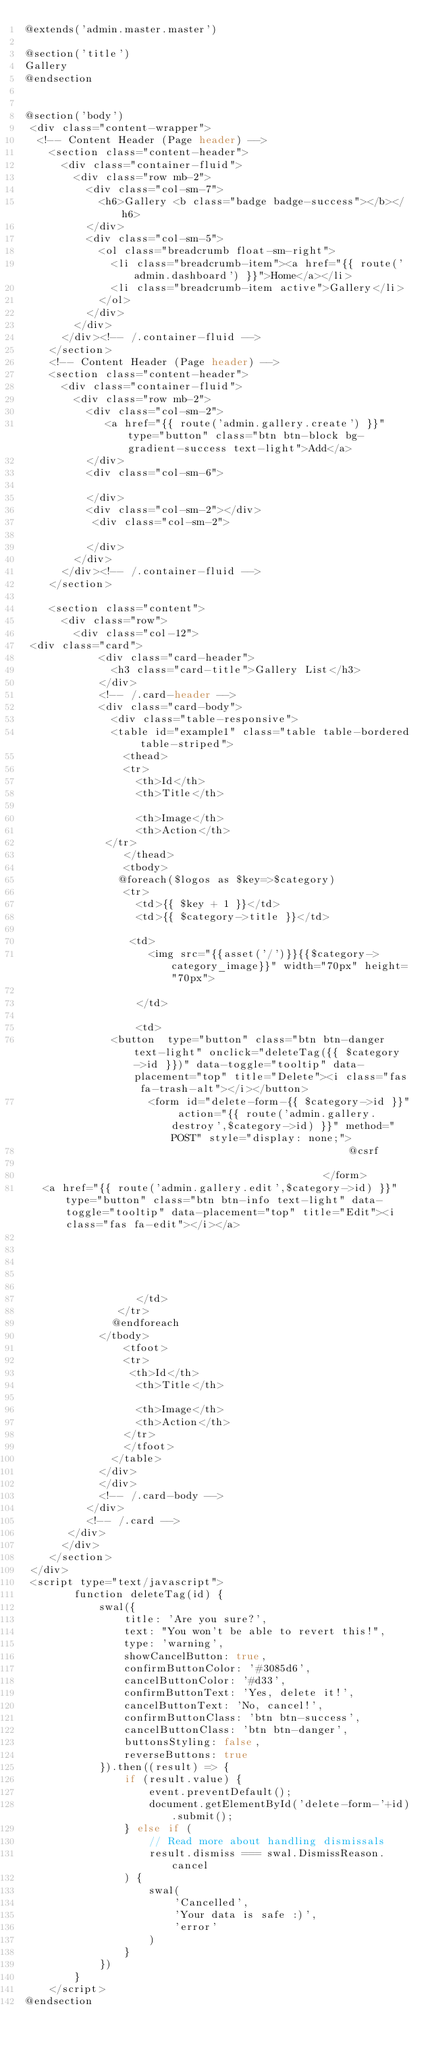<code> <loc_0><loc_0><loc_500><loc_500><_PHP_>@extends('admin.master.master')

@section('title')
Gallery 
@endsection


@section('body')
 <div class="content-wrapper">
  <!-- Content Header (Page header) -->
    <section class="content-header">
      <div class="container-fluid">
        <div class="row mb-2">
          <div class="col-sm-7">
            <h6>Gallery <b class="badge badge-success"></b></h6>
          </div>
          <div class="col-sm-5">
            <ol class="breadcrumb float-sm-right">
              <li class="breadcrumb-item"><a href="{{ route('admin.dashboard') }}">Home</a></li>
              <li class="breadcrumb-item active">Gallery</li>
            </ol>
          </div>
        </div>
      </div><!-- /.container-fluid -->
    </section>
    <!-- Content Header (Page header) -->
    <section class="content-header">
      <div class="container-fluid">
        <div class="row mb-2">
          <div class="col-sm-2">
             <a href="{{ route('admin.gallery.create') }}" type="button" class="btn btn-block bg-gradient-success text-light">Add</a>
          </div>
          <div class="col-sm-6">
            
          </div>
          <div class="col-sm-2"></div>
           <div class="col-sm-2">
           
          </div>
        </div>
      </div><!-- /.container-fluid -->
    </section>
  
    <section class="content">
      <div class="row">
        <div class="col-12">
 <div class="card">
            <div class="card-header">
              <h3 class="card-title">Gallery List</h3>
            </div>
            <!-- /.card-header -->
            <div class="card-body">
              <div class="table-responsive">
              <table id="example1" class="table table-bordered table-striped">
                <thead>
                <tr>
                  <th>Id</th>
                  <th>Title</th>
              
                  <th>Image</th>
                  <th>Action</th>
             </tr>
                </thead>
                <tbody>
               @foreach($logos as $key=>$category)
                <tr>
                  <td>{{ $key + 1 }}</td>
                  <td>{{ $category->title }}</td>
                
                 <td>
                    <img src="{{asset('/')}}{{$category->category_image}}" width="70px" height="70px">
                   
                  </td>
                 
                  <td>
              <button  type="button" class="btn btn-danger text-light" onclick="deleteTag({{ $category->id }})" data-toggle="tooltip" data-placement="top" title="Delete"><i class="fas fa-trash-alt"></i></button>
                    <form id="delete-form-{{ $category->id }}" action="{{ route('admin.gallery.destroy',$category->id) }}" method="POST" style="display: none;">
                                                    @csrf
                                                    
                                                </form>
   <a href="{{ route('admin.gallery.edit',$category->id) }}" type="button" class="btn btn-info text-light" data-toggle="tooltip" data-placement="top" title="Edit"><i class="fas fa-edit"></i></a>

                    
                
               
                
                  </td>
               </tr>
              @endforeach
            </tbody>
                <tfoot>
                <tr>
                 <th>Id</th>
                  <th>Title</th>
              
                  <th>Image</th>
                  <th>Action</th>
                </tr>
                </tfoot>
              </table>
            </div>
            </div>
            <!-- /.card-body -->
          </div>
          <!-- /.card -->
       </div>
      </div>
    </section>
 </div>
 <script type="text/javascript">
        function deleteTag(id) {
            swal({
                title: 'Are you sure?',
                text: "You won't be able to revert this!",
                type: 'warning',
                showCancelButton: true,
                confirmButtonColor: '#3085d6',
                cancelButtonColor: '#d33',
                confirmButtonText: 'Yes, delete it!',
                cancelButtonText: 'No, cancel!',
                confirmButtonClass: 'btn btn-success',
                cancelButtonClass: 'btn btn-danger',
                buttonsStyling: false,
                reverseButtons: true
            }).then((result) => {
                if (result.value) {
                    event.preventDefault();
                    document.getElementById('delete-form-'+id).submit();
                } else if (
                    // Read more about handling dismissals
                    result.dismiss === swal.DismissReason.cancel
                ) {
                    swal(
                        'Cancelled',
                        'Your data is safe :)',
                        'error'
                    )
                }
            })
        }
    </script>
@endsection</code> 